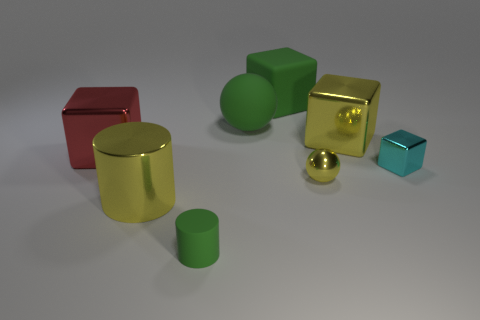Subtract 2 cubes. How many cubes are left? 2 Subtract all cyan cubes. How many cubes are left? 3 Subtract all big red metal blocks. How many blocks are left? 3 Add 1 yellow cylinders. How many objects exist? 9 Subtract all spheres. How many objects are left? 6 Subtract all yellow blocks. Subtract all green cylinders. How many blocks are left? 3 Subtract 0 brown cylinders. How many objects are left? 8 Subtract all large yellow metal cylinders. Subtract all cylinders. How many objects are left? 5 Add 5 big green rubber blocks. How many big green rubber blocks are left? 6 Add 6 red cubes. How many red cubes exist? 7 